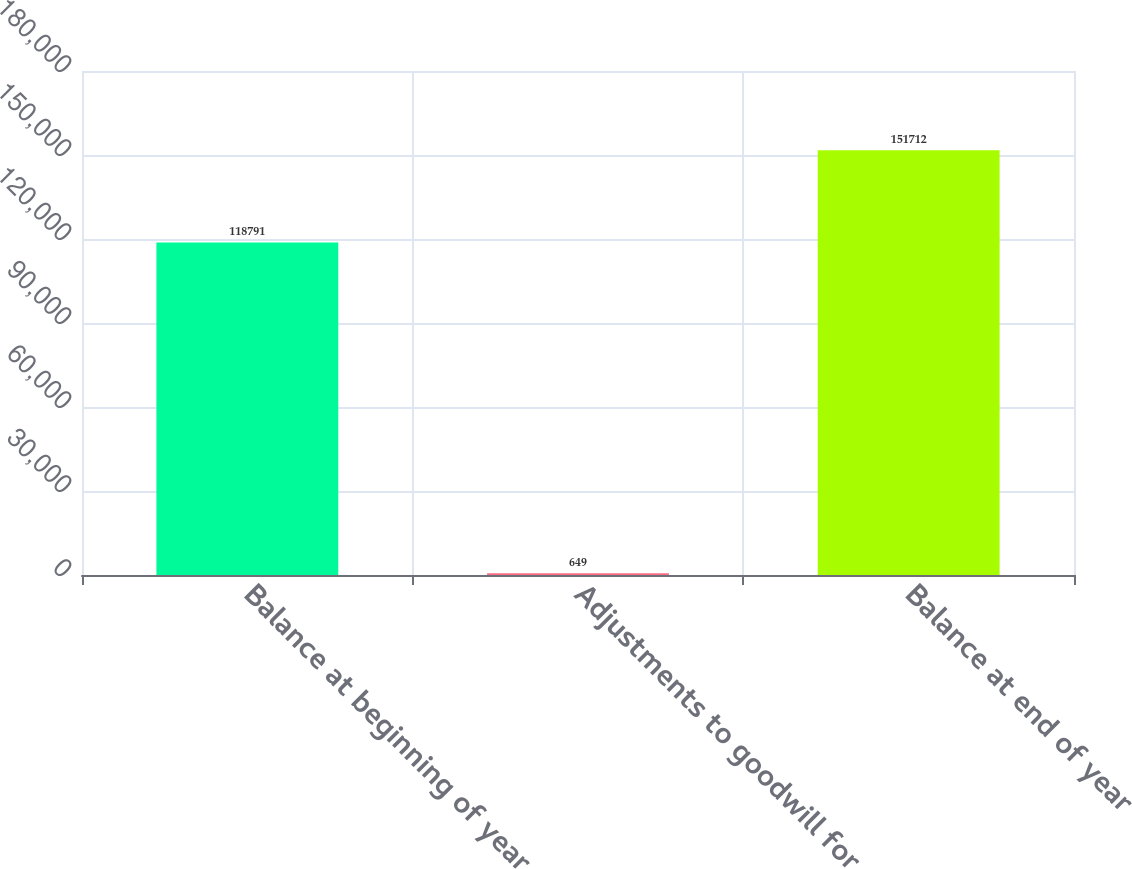Convert chart. <chart><loc_0><loc_0><loc_500><loc_500><bar_chart><fcel>Balance at beginning of year<fcel>Adjustments to goodwill for<fcel>Balance at end of year<nl><fcel>118791<fcel>649<fcel>151712<nl></chart> 